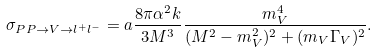Convert formula to latex. <formula><loc_0><loc_0><loc_500><loc_500>\sigma _ { P P \to V \to l ^ { + } l ^ { - } } = a \frac { 8 \pi \alpha ^ { 2 } k } { 3 M ^ { 3 } } \frac { m _ { V } ^ { 4 } } { ( M ^ { 2 } - m _ { V } ^ { 2 } ) ^ { 2 } + ( m _ { V } \Gamma _ { V } ) ^ { 2 } } .</formula> 